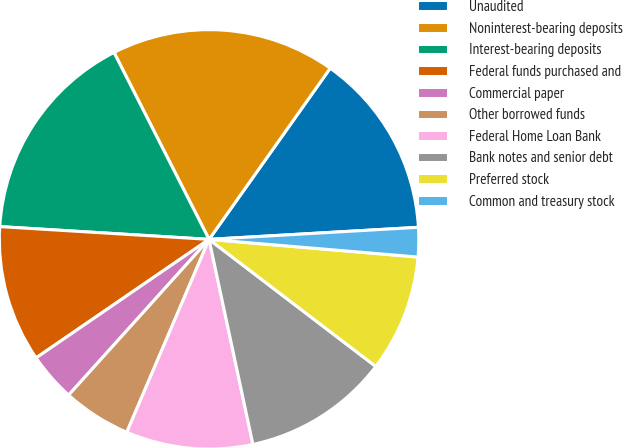Convert chart to OTSL. <chart><loc_0><loc_0><loc_500><loc_500><pie_chart><fcel>Unaudited<fcel>Noninterest-bearing deposits<fcel>Interest-bearing deposits<fcel>Federal funds purchased and<fcel>Commercial paper<fcel>Other borrowed funds<fcel>Federal Home Loan Bank<fcel>Bank notes and senior debt<fcel>Preferred stock<fcel>Common and treasury stock<nl><fcel>14.28%<fcel>17.29%<fcel>16.54%<fcel>10.53%<fcel>3.76%<fcel>5.26%<fcel>9.77%<fcel>11.28%<fcel>9.02%<fcel>2.26%<nl></chart> 